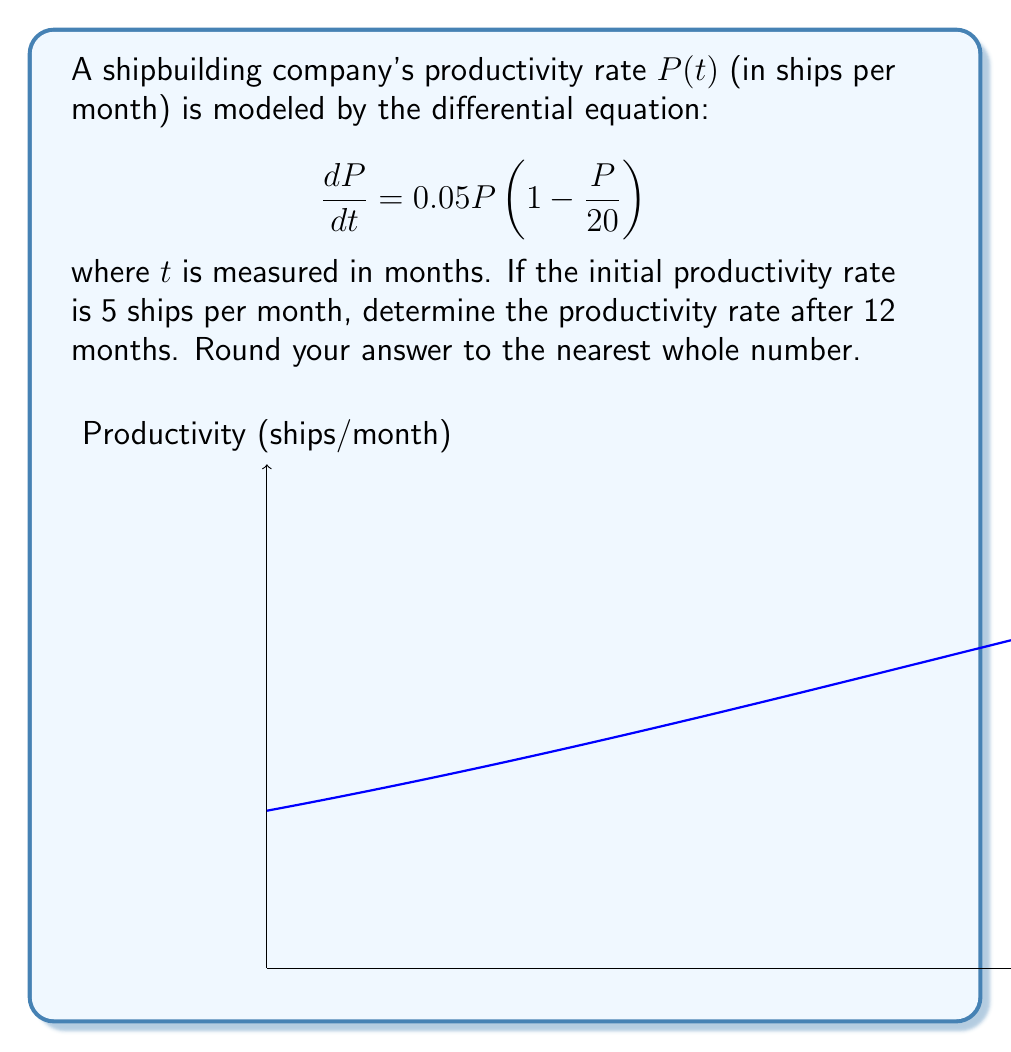Provide a solution to this math problem. To solve this problem, we need to follow these steps:

1) First, recognize that this is a logistic growth model with carrying capacity K = 20 and growth rate r = 0.05.

2) The general solution for the logistic equation is:

   $$P(t) = \frac{K}{1 + Ce^{-rt}}$$

   where $K$ is the carrying capacity, $r$ is the growth rate, and $C$ is a constant determined by the initial condition.

3) We know that $P(0) = 5$. Let's use this to find $C$:

   $$5 = \frac{20}{1 + C}$$
   $$1 + C = 4$$
   $$C = 3$$

4) Now we have our specific solution:

   $$P(t) = \frac{20}{1 + 3e^{-0.05t}}$$

5) To find $P(12)$, we simply substitute $t = 12$:

   $$P(12) = \frac{20}{1 + 3e^{-0.05(12)}}$$

6) Calculating this:
   
   $$P(12) = \frac{20}{1 + 3e^{-0.6}} \approx 11.92$$

7) Rounding to the nearest whole number gives us 12.
Answer: 12 ships per month 